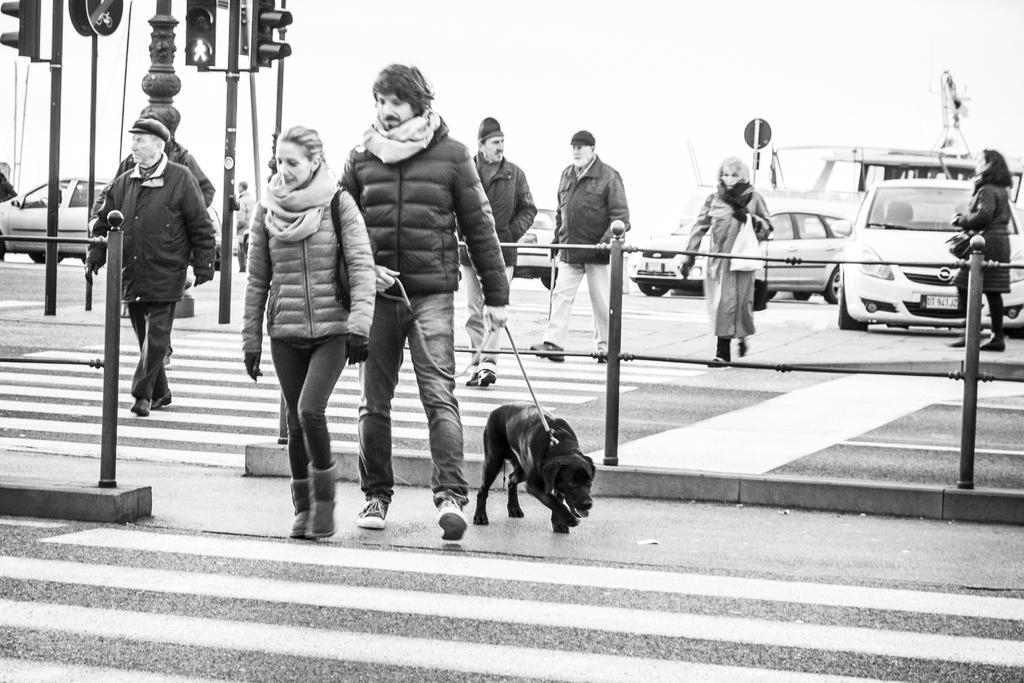Please provide a concise description of this image. In this image I see few people who are on the path and this man over here is holding a rope which is tied to the dog. In the background I can see the traffic signals, a pole and few cars. 